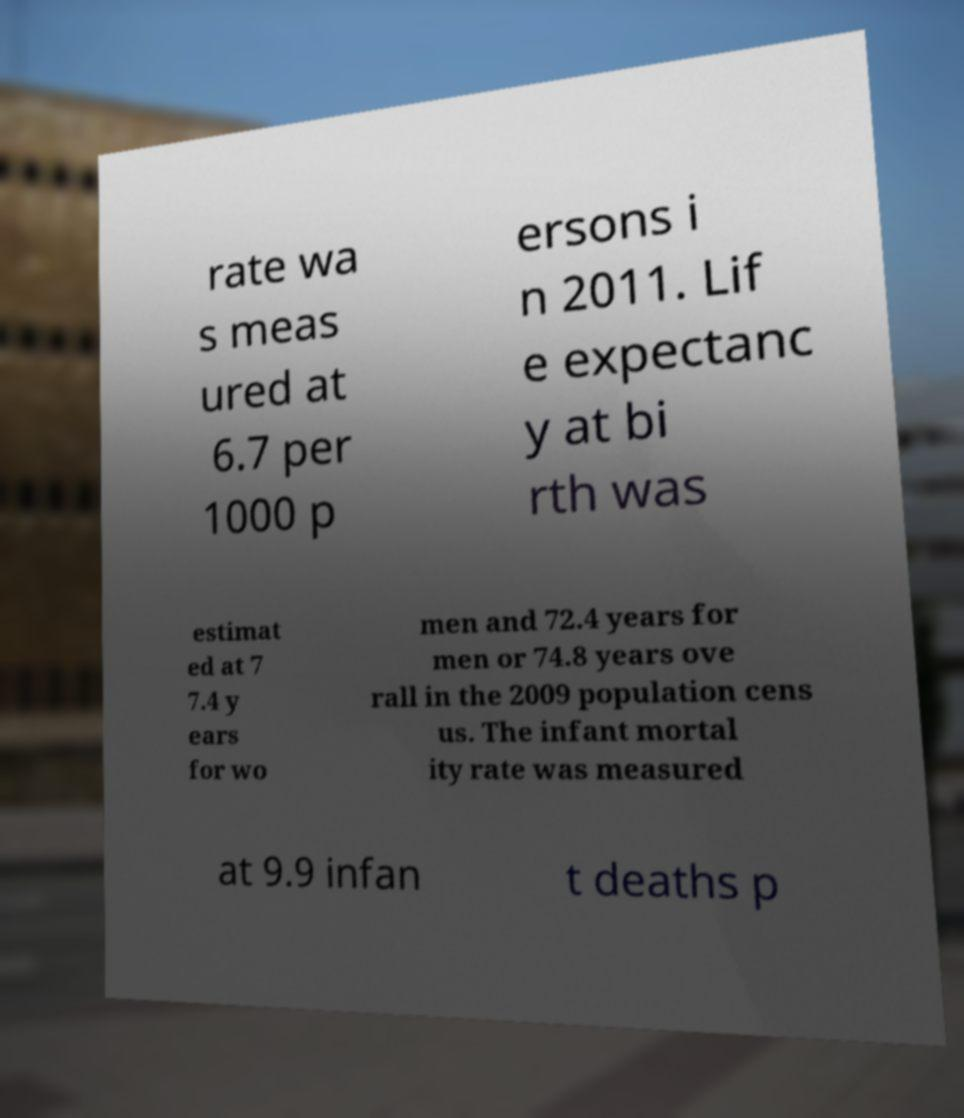Can you accurately transcribe the text from the provided image for me? rate wa s meas ured at 6.7 per 1000 p ersons i n 2011. Lif e expectanc y at bi rth was estimat ed at 7 7.4 y ears for wo men and 72.4 years for men or 74.8 years ove rall in the 2009 population cens us. The infant mortal ity rate was measured at 9.9 infan t deaths p 